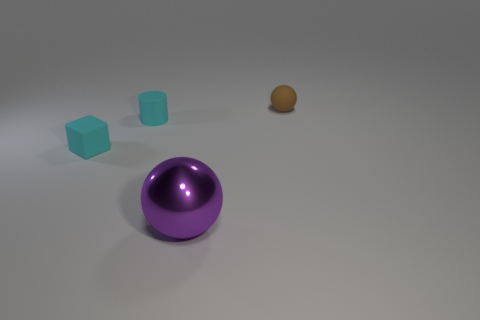Are the tiny thing that is in front of the small cyan rubber cylinder and the tiny thing behind the cyan cylinder made of the same material?
Provide a short and direct response. Yes. What is the size of the sphere on the left side of the small matte thing that is right of the large purple ball?
Provide a succinct answer. Large. Are there any tiny things of the same color as the block?
Your answer should be compact. Yes. There is a thing that is to the left of the tiny matte cylinder; does it have the same color as the small cylinder behind the shiny object?
Provide a succinct answer. Yes. There is a matte sphere; what number of cyan cubes are to the left of it?
Offer a terse response. 1. How many cyan blocks are made of the same material as the tiny cylinder?
Provide a short and direct response. 1. Does the sphere on the right side of the large purple sphere have the same material as the cube?
Provide a succinct answer. Yes. Are any gray cylinders visible?
Offer a very short reply. No. There is a object that is on the right side of the cyan cylinder and in front of the small matte cylinder; what is its size?
Keep it short and to the point. Large. Is the number of rubber things that are in front of the small ball greater than the number of tiny cubes to the right of the big purple ball?
Provide a short and direct response. Yes. 